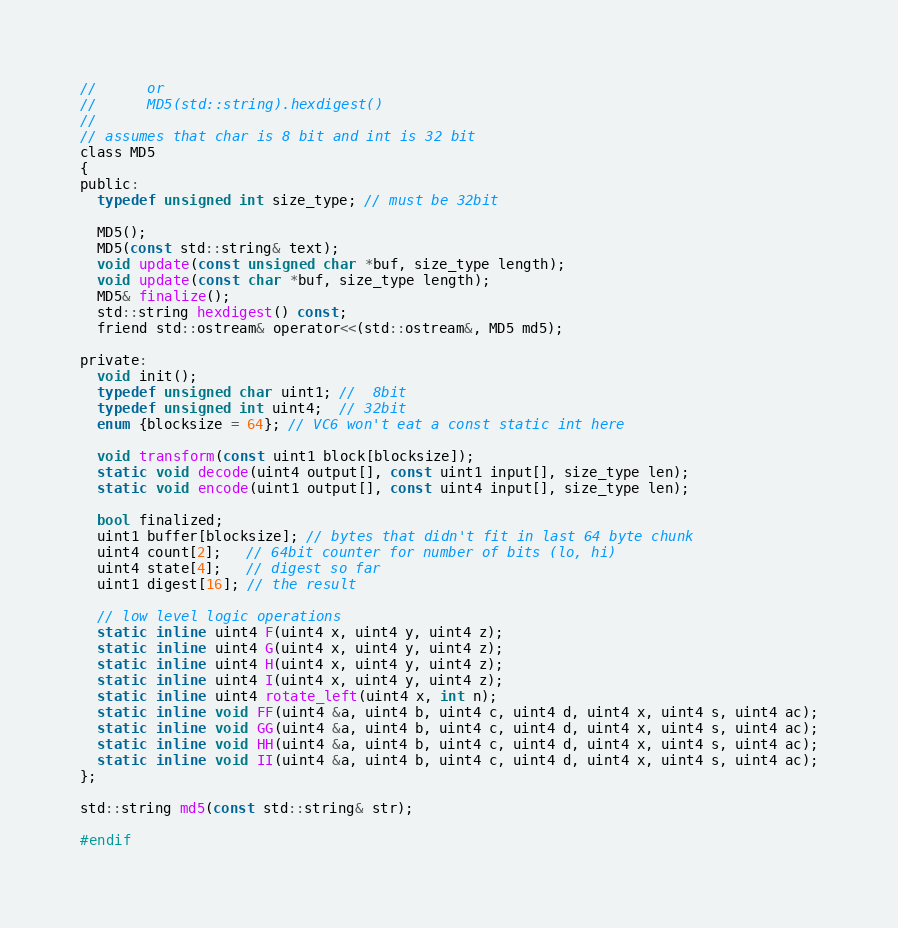<code> <loc_0><loc_0><loc_500><loc_500><_C_>//      or
//      MD5(std::string).hexdigest()
//
// assumes that char is 8 bit and int is 32 bit
class MD5
{
public:
  typedef unsigned int size_type; // must be 32bit

  MD5();
  MD5(const std::string& text);
  void update(const unsigned char *buf, size_type length);
  void update(const char *buf, size_type length);
  MD5& finalize();
  std::string hexdigest() const;
  friend std::ostream& operator<<(std::ostream&, MD5 md5);

private:
  void init();
  typedef unsigned char uint1; //  8bit
  typedef unsigned int uint4;  // 32bit
  enum {blocksize = 64}; // VC6 won't eat a const static int here

  void transform(const uint1 block[blocksize]);
  static void decode(uint4 output[], const uint1 input[], size_type len);
  static void encode(uint1 output[], const uint4 input[], size_type len);

  bool finalized;
  uint1 buffer[blocksize]; // bytes that didn't fit in last 64 byte chunk
  uint4 count[2];   // 64bit counter for number of bits (lo, hi)
  uint4 state[4];   // digest so far
  uint1 digest[16]; // the result

  // low level logic operations
  static inline uint4 F(uint4 x, uint4 y, uint4 z);
  static inline uint4 G(uint4 x, uint4 y, uint4 z);
  static inline uint4 H(uint4 x, uint4 y, uint4 z);
  static inline uint4 I(uint4 x, uint4 y, uint4 z);
  static inline uint4 rotate_left(uint4 x, int n);
  static inline void FF(uint4 &a, uint4 b, uint4 c, uint4 d, uint4 x, uint4 s, uint4 ac);
  static inline void GG(uint4 &a, uint4 b, uint4 c, uint4 d, uint4 x, uint4 s, uint4 ac);
  static inline void HH(uint4 &a, uint4 b, uint4 c, uint4 d, uint4 x, uint4 s, uint4 ac);
  static inline void II(uint4 &a, uint4 b, uint4 c, uint4 d, uint4 x, uint4 s, uint4 ac);
};

std::string md5(const std::string& str);

#endif
</code> 